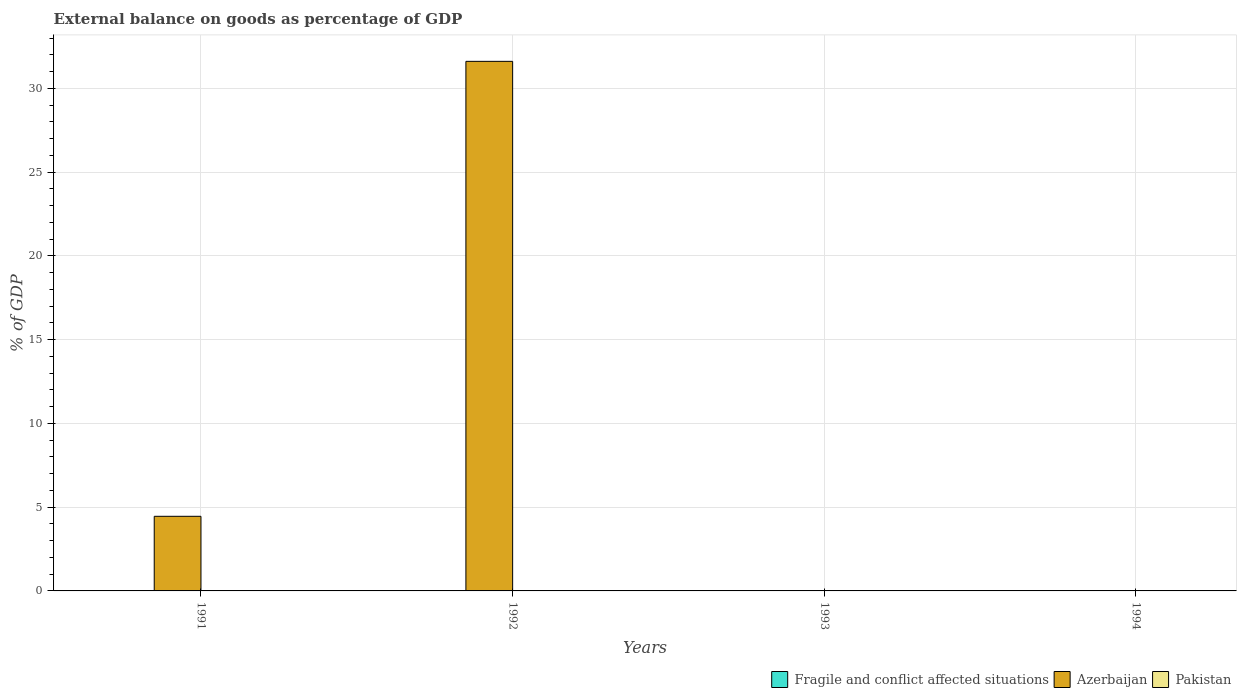How many different coloured bars are there?
Your response must be concise. 1. Are the number of bars per tick equal to the number of legend labels?
Keep it short and to the point. No. Are the number of bars on each tick of the X-axis equal?
Offer a terse response. No. How many bars are there on the 2nd tick from the right?
Ensure brevity in your answer.  0. In how many cases, is the number of bars for a given year not equal to the number of legend labels?
Provide a short and direct response. 4. Across all years, what is the maximum external balance on goods as percentage of GDP in Azerbaijan?
Keep it short and to the point. 31.61. What is the difference between the external balance on goods as percentage of GDP in Pakistan in 1992 and the external balance on goods as percentage of GDP in Fragile and conflict affected situations in 1991?
Give a very brief answer. 0. In how many years, is the external balance on goods as percentage of GDP in Pakistan greater than 12 %?
Make the answer very short. 0. In how many years, is the external balance on goods as percentage of GDP in Pakistan greater than the average external balance on goods as percentage of GDP in Pakistan taken over all years?
Your answer should be compact. 0. How many bars are there?
Ensure brevity in your answer.  2. How many years are there in the graph?
Provide a succinct answer. 4. Does the graph contain any zero values?
Ensure brevity in your answer.  Yes. Where does the legend appear in the graph?
Offer a terse response. Bottom right. What is the title of the graph?
Provide a short and direct response. External balance on goods as percentage of GDP. What is the label or title of the Y-axis?
Give a very brief answer. % of GDP. What is the % of GDP of Azerbaijan in 1991?
Ensure brevity in your answer.  4.45. What is the % of GDP in Azerbaijan in 1992?
Keep it short and to the point. 31.61. What is the % of GDP of Pakistan in 1992?
Offer a very short reply. 0. What is the % of GDP of Fragile and conflict affected situations in 1993?
Your answer should be compact. 0. What is the % of GDP in Azerbaijan in 1993?
Your answer should be compact. 0. What is the % of GDP of Azerbaijan in 1994?
Make the answer very short. 0. What is the % of GDP in Pakistan in 1994?
Your answer should be compact. 0. Across all years, what is the maximum % of GDP in Azerbaijan?
Your response must be concise. 31.61. What is the total % of GDP of Fragile and conflict affected situations in the graph?
Your answer should be very brief. 0. What is the total % of GDP in Azerbaijan in the graph?
Offer a terse response. 36.06. What is the difference between the % of GDP of Azerbaijan in 1991 and that in 1992?
Ensure brevity in your answer.  -27.15. What is the average % of GDP in Azerbaijan per year?
Make the answer very short. 9.02. What is the ratio of the % of GDP of Azerbaijan in 1991 to that in 1992?
Offer a very short reply. 0.14. What is the difference between the highest and the lowest % of GDP in Azerbaijan?
Provide a short and direct response. 31.61. 